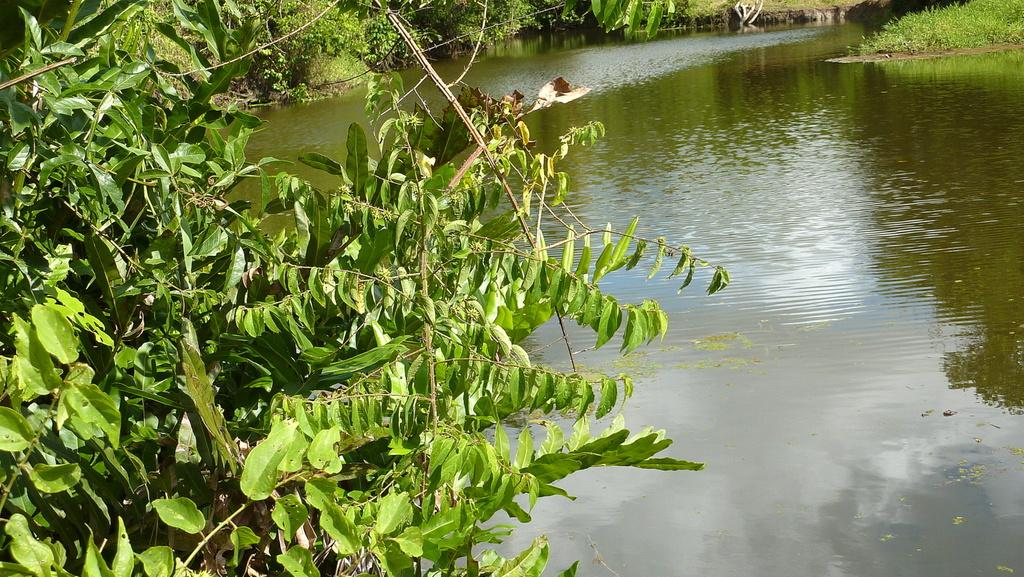What type of vegetation can be seen in the left corner of the image? There are trees in the left corner of the image. What type of vegetation can be seen in the right corner of the image? There is green grass in the right corner of the image. What is visible at the bottom of the image? There is water visible at the bottom of the image. What can be seen in the background of the image? There are trees in the background of the image. What type of secretary can be seen working in the water at the bottom of the image? There is no secretary present in the image; it features trees, grass, and water. What type of wax is visible on the trees in the background of the image? There is no wax visible on the trees in the background of the image; only trees are present. 